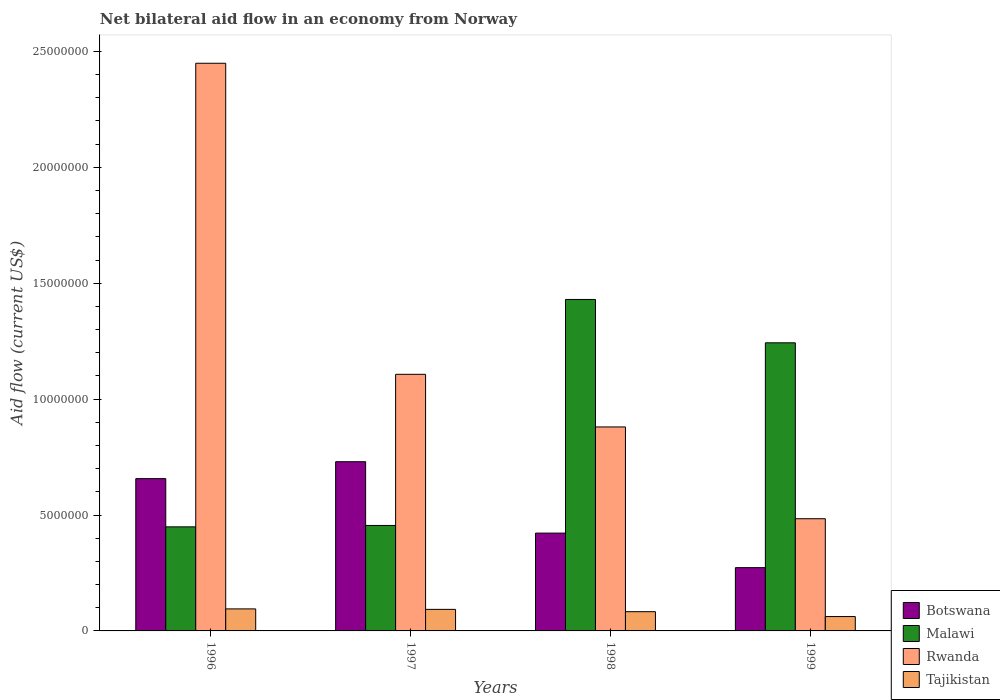How many different coloured bars are there?
Give a very brief answer. 4. How many groups of bars are there?
Offer a very short reply. 4. Are the number of bars per tick equal to the number of legend labels?
Offer a very short reply. Yes. How many bars are there on the 4th tick from the left?
Your answer should be very brief. 4. What is the net bilateral aid flow in Malawi in 1997?
Offer a terse response. 4.55e+06. Across all years, what is the maximum net bilateral aid flow in Botswana?
Your answer should be compact. 7.30e+06. Across all years, what is the minimum net bilateral aid flow in Malawi?
Make the answer very short. 4.49e+06. In which year was the net bilateral aid flow in Rwanda maximum?
Provide a short and direct response. 1996. What is the total net bilateral aid flow in Rwanda in the graph?
Give a very brief answer. 4.92e+07. What is the difference between the net bilateral aid flow in Botswana in 1996 and that in 1998?
Your answer should be compact. 2.35e+06. What is the difference between the net bilateral aid flow in Tajikistan in 1997 and the net bilateral aid flow in Malawi in 1999?
Make the answer very short. -1.15e+07. What is the average net bilateral aid flow in Tajikistan per year?
Your answer should be compact. 8.32e+05. In the year 1997, what is the difference between the net bilateral aid flow in Malawi and net bilateral aid flow in Tajikistan?
Your response must be concise. 3.62e+06. In how many years, is the net bilateral aid flow in Tajikistan greater than 3000000 US$?
Provide a short and direct response. 0. What is the ratio of the net bilateral aid flow in Tajikistan in 1996 to that in 1999?
Offer a very short reply. 1.53. Is the net bilateral aid flow in Tajikistan in 1998 less than that in 1999?
Your answer should be very brief. No. Is the difference between the net bilateral aid flow in Malawi in 1996 and 1998 greater than the difference between the net bilateral aid flow in Tajikistan in 1996 and 1998?
Your answer should be compact. No. What is the difference between the highest and the second highest net bilateral aid flow in Malawi?
Ensure brevity in your answer.  1.87e+06. What is the difference between the highest and the lowest net bilateral aid flow in Tajikistan?
Provide a short and direct response. 3.30e+05. What does the 2nd bar from the left in 1996 represents?
Make the answer very short. Malawi. What does the 4th bar from the right in 1998 represents?
Offer a terse response. Botswana. How many bars are there?
Give a very brief answer. 16. Are the values on the major ticks of Y-axis written in scientific E-notation?
Your answer should be compact. No. Where does the legend appear in the graph?
Offer a very short reply. Bottom right. How many legend labels are there?
Offer a very short reply. 4. What is the title of the graph?
Offer a very short reply. Net bilateral aid flow in an economy from Norway. Does "Haiti" appear as one of the legend labels in the graph?
Offer a terse response. No. What is the label or title of the Y-axis?
Offer a very short reply. Aid flow (current US$). What is the Aid flow (current US$) of Botswana in 1996?
Keep it short and to the point. 6.57e+06. What is the Aid flow (current US$) of Malawi in 1996?
Your answer should be very brief. 4.49e+06. What is the Aid flow (current US$) in Rwanda in 1996?
Give a very brief answer. 2.45e+07. What is the Aid flow (current US$) of Tajikistan in 1996?
Ensure brevity in your answer.  9.50e+05. What is the Aid flow (current US$) of Botswana in 1997?
Your answer should be compact. 7.30e+06. What is the Aid flow (current US$) of Malawi in 1997?
Your answer should be compact. 4.55e+06. What is the Aid flow (current US$) in Rwanda in 1997?
Offer a terse response. 1.11e+07. What is the Aid flow (current US$) of Tajikistan in 1997?
Ensure brevity in your answer.  9.30e+05. What is the Aid flow (current US$) in Botswana in 1998?
Your answer should be very brief. 4.22e+06. What is the Aid flow (current US$) in Malawi in 1998?
Your response must be concise. 1.43e+07. What is the Aid flow (current US$) in Rwanda in 1998?
Give a very brief answer. 8.80e+06. What is the Aid flow (current US$) of Tajikistan in 1998?
Give a very brief answer. 8.30e+05. What is the Aid flow (current US$) of Botswana in 1999?
Offer a very short reply. 2.73e+06. What is the Aid flow (current US$) of Malawi in 1999?
Keep it short and to the point. 1.24e+07. What is the Aid flow (current US$) in Rwanda in 1999?
Make the answer very short. 4.84e+06. What is the Aid flow (current US$) of Tajikistan in 1999?
Keep it short and to the point. 6.20e+05. Across all years, what is the maximum Aid flow (current US$) in Botswana?
Provide a succinct answer. 7.30e+06. Across all years, what is the maximum Aid flow (current US$) in Malawi?
Make the answer very short. 1.43e+07. Across all years, what is the maximum Aid flow (current US$) of Rwanda?
Your response must be concise. 2.45e+07. Across all years, what is the maximum Aid flow (current US$) in Tajikistan?
Your answer should be compact. 9.50e+05. Across all years, what is the minimum Aid flow (current US$) in Botswana?
Your response must be concise. 2.73e+06. Across all years, what is the minimum Aid flow (current US$) in Malawi?
Make the answer very short. 4.49e+06. Across all years, what is the minimum Aid flow (current US$) of Rwanda?
Your answer should be compact. 4.84e+06. Across all years, what is the minimum Aid flow (current US$) of Tajikistan?
Your answer should be very brief. 6.20e+05. What is the total Aid flow (current US$) of Botswana in the graph?
Your response must be concise. 2.08e+07. What is the total Aid flow (current US$) of Malawi in the graph?
Your answer should be very brief. 3.58e+07. What is the total Aid flow (current US$) of Rwanda in the graph?
Offer a terse response. 4.92e+07. What is the total Aid flow (current US$) of Tajikistan in the graph?
Your answer should be very brief. 3.33e+06. What is the difference between the Aid flow (current US$) of Botswana in 1996 and that in 1997?
Your answer should be very brief. -7.30e+05. What is the difference between the Aid flow (current US$) in Malawi in 1996 and that in 1997?
Give a very brief answer. -6.00e+04. What is the difference between the Aid flow (current US$) of Rwanda in 1996 and that in 1997?
Ensure brevity in your answer.  1.34e+07. What is the difference between the Aid flow (current US$) of Tajikistan in 1996 and that in 1997?
Your response must be concise. 2.00e+04. What is the difference between the Aid flow (current US$) of Botswana in 1996 and that in 1998?
Your answer should be compact. 2.35e+06. What is the difference between the Aid flow (current US$) of Malawi in 1996 and that in 1998?
Give a very brief answer. -9.81e+06. What is the difference between the Aid flow (current US$) of Rwanda in 1996 and that in 1998?
Keep it short and to the point. 1.57e+07. What is the difference between the Aid flow (current US$) in Botswana in 1996 and that in 1999?
Ensure brevity in your answer.  3.84e+06. What is the difference between the Aid flow (current US$) of Malawi in 1996 and that in 1999?
Provide a short and direct response. -7.94e+06. What is the difference between the Aid flow (current US$) of Rwanda in 1996 and that in 1999?
Your answer should be very brief. 1.96e+07. What is the difference between the Aid flow (current US$) of Tajikistan in 1996 and that in 1999?
Your response must be concise. 3.30e+05. What is the difference between the Aid flow (current US$) in Botswana in 1997 and that in 1998?
Your response must be concise. 3.08e+06. What is the difference between the Aid flow (current US$) in Malawi in 1997 and that in 1998?
Keep it short and to the point. -9.75e+06. What is the difference between the Aid flow (current US$) of Rwanda in 1997 and that in 1998?
Provide a succinct answer. 2.27e+06. What is the difference between the Aid flow (current US$) of Botswana in 1997 and that in 1999?
Your answer should be compact. 4.57e+06. What is the difference between the Aid flow (current US$) of Malawi in 1997 and that in 1999?
Your answer should be compact. -7.88e+06. What is the difference between the Aid flow (current US$) in Rwanda in 1997 and that in 1999?
Make the answer very short. 6.23e+06. What is the difference between the Aid flow (current US$) of Botswana in 1998 and that in 1999?
Give a very brief answer. 1.49e+06. What is the difference between the Aid flow (current US$) in Malawi in 1998 and that in 1999?
Offer a terse response. 1.87e+06. What is the difference between the Aid flow (current US$) of Rwanda in 1998 and that in 1999?
Make the answer very short. 3.96e+06. What is the difference between the Aid flow (current US$) in Tajikistan in 1998 and that in 1999?
Your response must be concise. 2.10e+05. What is the difference between the Aid flow (current US$) of Botswana in 1996 and the Aid flow (current US$) of Malawi in 1997?
Provide a succinct answer. 2.02e+06. What is the difference between the Aid flow (current US$) in Botswana in 1996 and the Aid flow (current US$) in Rwanda in 1997?
Offer a terse response. -4.50e+06. What is the difference between the Aid flow (current US$) of Botswana in 1996 and the Aid flow (current US$) of Tajikistan in 1997?
Make the answer very short. 5.64e+06. What is the difference between the Aid flow (current US$) in Malawi in 1996 and the Aid flow (current US$) in Rwanda in 1997?
Make the answer very short. -6.58e+06. What is the difference between the Aid flow (current US$) in Malawi in 1996 and the Aid flow (current US$) in Tajikistan in 1997?
Your response must be concise. 3.56e+06. What is the difference between the Aid flow (current US$) of Rwanda in 1996 and the Aid flow (current US$) of Tajikistan in 1997?
Your answer should be very brief. 2.36e+07. What is the difference between the Aid flow (current US$) of Botswana in 1996 and the Aid flow (current US$) of Malawi in 1998?
Offer a very short reply. -7.73e+06. What is the difference between the Aid flow (current US$) of Botswana in 1996 and the Aid flow (current US$) of Rwanda in 1998?
Offer a very short reply. -2.23e+06. What is the difference between the Aid flow (current US$) in Botswana in 1996 and the Aid flow (current US$) in Tajikistan in 1998?
Keep it short and to the point. 5.74e+06. What is the difference between the Aid flow (current US$) of Malawi in 1996 and the Aid flow (current US$) of Rwanda in 1998?
Provide a short and direct response. -4.31e+06. What is the difference between the Aid flow (current US$) of Malawi in 1996 and the Aid flow (current US$) of Tajikistan in 1998?
Offer a terse response. 3.66e+06. What is the difference between the Aid flow (current US$) of Rwanda in 1996 and the Aid flow (current US$) of Tajikistan in 1998?
Your answer should be very brief. 2.37e+07. What is the difference between the Aid flow (current US$) in Botswana in 1996 and the Aid flow (current US$) in Malawi in 1999?
Offer a very short reply. -5.86e+06. What is the difference between the Aid flow (current US$) of Botswana in 1996 and the Aid flow (current US$) of Rwanda in 1999?
Keep it short and to the point. 1.73e+06. What is the difference between the Aid flow (current US$) in Botswana in 1996 and the Aid flow (current US$) in Tajikistan in 1999?
Your answer should be very brief. 5.95e+06. What is the difference between the Aid flow (current US$) of Malawi in 1996 and the Aid flow (current US$) of Rwanda in 1999?
Ensure brevity in your answer.  -3.50e+05. What is the difference between the Aid flow (current US$) of Malawi in 1996 and the Aid flow (current US$) of Tajikistan in 1999?
Your response must be concise. 3.87e+06. What is the difference between the Aid flow (current US$) in Rwanda in 1996 and the Aid flow (current US$) in Tajikistan in 1999?
Keep it short and to the point. 2.39e+07. What is the difference between the Aid flow (current US$) of Botswana in 1997 and the Aid flow (current US$) of Malawi in 1998?
Provide a succinct answer. -7.00e+06. What is the difference between the Aid flow (current US$) of Botswana in 1997 and the Aid flow (current US$) of Rwanda in 1998?
Your answer should be compact. -1.50e+06. What is the difference between the Aid flow (current US$) in Botswana in 1997 and the Aid flow (current US$) in Tajikistan in 1998?
Your answer should be compact. 6.47e+06. What is the difference between the Aid flow (current US$) of Malawi in 1997 and the Aid flow (current US$) of Rwanda in 1998?
Give a very brief answer. -4.25e+06. What is the difference between the Aid flow (current US$) of Malawi in 1997 and the Aid flow (current US$) of Tajikistan in 1998?
Give a very brief answer. 3.72e+06. What is the difference between the Aid flow (current US$) in Rwanda in 1997 and the Aid flow (current US$) in Tajikistan in 1998?
Offer a terse response. 1.02e+07. What is the difference between the Aid flow (current US$) in Botswana in 1997 and the Aid flow (current US$) in Malawi in 1999?
Provide a short and direct response. -5.13e+06. What is the difference between the Aid flow (current US$) of Botswana in 1997 and the Aid flow (current US$) of Rwanda in 1999?
Provide a short and direct response. 2.46e+06. What is the difference between the Aid flow (current US$) of Botswana in 1997 and the Aid flow (current US$) of Tajikistan in 1999?
Make the answer very short. 6.68e+06. What is the difference between the Aid flow (current US$) in Malawi in 1997 and the Aid flow (current US$) in Rwanda in 1999?
Your answer should be compact. -2.90e+05. What is the difference between the Aid flow (current US$) in Malawi in 1997 and the Aid flow (current US$) in Tajikistan in 1999?
Make the answer very short. 3.93e+06. What is the difference between the Aid flow (current US$) of Rwanda in 1997 and the Aid flow (current US$) of Tajikistan in 1999?
Ensure brevity in your answer.  1.04e+07. What is the difference between the Aid flow (current US$) of Botswana in 1998 and the Aid flow (current US$) of Malawi in 1999?
Provide a short and direct response. -8.21e+06. What is the difference between the Aid flow (current US$) in Botswana in 1998 and the Aid flow (current US$) in Rwanda in 1999?
Make the answer very short. -6.20e+05. What is the difference between the Aid flow (current US$) in Botswana in 1998 and the Aid flow (current US$) in Tajikistan in 1999?
Give a very brief answer. 3.60e+06. What is the difference between the Aid flow (current US$) in Malawi in 1998 and the Aid flow (current US$) in Rwanda in 1999?
Give a very brief answer. 9.46e+06. What is the difference between the Aid flow (current US$) of Malawi in 1998 and the Aid flow (current US$) of Tajikistan in 1999?
Provide a short and direct response. 1.37e+07. What is the difference between the Aid flow (current US$) of Rwanda in 1998 and the Aid flow (current US$) of Tajikistan in 1999?
Offer a terse response. 8.18e+06. What is the average Aid flow (current US$) of Botswana per year?
Ensure brevity in your answer.  5.20e+06. What is the average Aid flow (current US$) of Malawi per year?
Your answer should be compact. 8.94e+06. What is the average Aid flow (current US$) in Rwanda per year?
Offer a very short reply. 1.23e+07. What is the average Aid flow (current US$) in Tajikistan per year?
Make the answer very short. 8.32e+05. In the year 1996, what is the difference between the Aid flow (current US$) in Botswana and Aid flow (current US$) in Malawi?
Make the answer very short. 2.08e+06. In the year 1996, what is the difference between the Aid flow (current US$) in Botswana and Aid flow (current US$) in Rwanda?
Your answer should be compact. -1.79e+07. In the year 1996, what is the difference between the Aid flow (current US$) of Botswana and Aid flow (current US$) of Tajikistan?
Provide a short and direct response. 5.62e+06. In the year 1996, what is the difference between the Aid flow (current US$) of Malawi and Aid flow (current US$) of Rwanda?
Provide a short and direct response. -2.00e+07. In the year 1996, what is the difference between the Aid flow (current US$) of Malawi and Aid flow (current US$) of Tajikistan?
Provide a short and direct response. 3.54e+06. In the year 1996, what is the difference between the Aid flow (current US$) in Rwanda and Aid flow (current US$) in Tajikistan?
Your answer should be very brief. 2.35e+07. In the year 1997, what is the difference between the Aid flow (current US$) of Botswana and Aid flow (current US$) of Malawi?
Offer a terse response. 2.75e+06. In the year 1997, what is the difference between the Aid flow (current US$) of Botswana and Aid flow (current US$) of Rwanda?
Your answer should be very brief. -3.77e+06. In the year 1997, what is the difference between the Aid flow (current US$) of Botswana and Aid flow (current US$) of Tajikistan?
Make the answer very short. 6.37e+06. In the year 1997, what is the difference between the Aid flow (current US$) in Malawi and Aid flow (current US$) in Rwanda?
Provide a short and direct response. -6.52e+06. In the year 1997, what is the difference between the Aid flow (current US$) of Malawi and Aid flow (current US$) of Tajikistan?
Offer a terse response. 3.62e+06. In the year 1997, what is the difference between the Aid flow (current US$) of Rwanda and Aid flow (current US$) of Tajikistan?
Provide a short and direct response. 1.01e+07. In the year 1998, what is the difference between the Aid flow (current US$) of Botswana and Aid flow (current US$) of Malawi?
Your answer should be very brief. -1.01e+07. In the year 1998, what is the difference between the Aid flow (current US$) in Botswana and Aid flow (current US$) in Rwanda?
Your response must be concise. -4.58e+06. In the year 1998, what is the difference between the Aid flow (current US$) in Botswana and Aid flow (current US$) in Tajikistan?
Make the answer very short. 3.39e+06. In the year 1998, what is the difference between the Aid flow (current US$) in Malawi and Aid flow (current US$) in Rwanda?
Your answer should be compact. 5.50e+06. In the year 1998, what is the difference between the Aid flow (current US$) in Malawi and Aid flow (current US$) in Tajikistan?
Ensure brevity in your answer.  1.35e+07. In the year 1998, what is the difference between the Aid flow (current US$) of Rwanda and Aid flow (current US$) of Tajikistan?
Keep it short and to the point. 7.97e+06. In the year 1999, what is the difference between the Aid flow (current US$) in Botswana and Aid flow (current US$) in Malawi?
Make the answer very short. -9.70e+06. In the year 1999, what is the difference between the Aid flow (current US$) in Botswana and Aid flow (current US$) in Rwanda?
Provide a short and direct response. -2.11e+06. In the year 1999, what is the difference between the Aid flow (current US$) of Botswana and Aid flow (current US$) of Tajikistan?
Offer a terse response. 2.11e+06. In the year 1999, what is the difference between the Aid flow (current US$) of Malawi and Aid flow (current US$) of Rwanda?
Offer a terse response. 7.59e+06. In the year 1999, what is the difference between the Aid flow (current US$) of Malawi and Aid flow (current US$) of Tajikistan?
Your answer should be very brief. 1.18e+07. In the year 1999, what is the difference between the Aid flow (current US$) in Rwanda and Aid flow (current US$) in Tajikistan?
Offer a terse response. 4.22e+06. What is the ratio of the Aid flow (current US$) of Rwanda in 1996 to that in 1997?
Keep it short and to the point. 2.21. What is the ratio of the Aid flow (current US$) of Tajikistan in 1996 to that in 1997?
Offer a very short reply. 1.02. What is the ratio of the Aid flow (current US$) in Botswana in 1996 to that in 1998?
Provide a succinct answer. 1.56. What is the ratio of the Aid flow (current US$) in Malawi in 1996 to that in 1998?
Your response must be concise. 0.31. What is the ratio of the Aid flow (current US$) in Rwanda in 1996 to that in 1998?
Offer a very short reply. 2.78. What is the ratio of the Aid flow (current US$) of Tajikistan in 1996 to that in 1998?
Offer a terse response. 1.14. What is the ratio of the Aid flow (current US$) in Botswana in 1996 to that in 1999?
Ensure brevity in your answer.  2.41. What is the ratio of the Aid flow (current US$) of Malawi in 1996 to that in 1999?
Offer a terse response. 0.36. What is the ratio of the Aid flow (current US$) of Rwanda in 1996 to that in 1999?
Give a very brief answer. 5.06. What is the ratio of the Aid flow (current US$) in Tajikistan in 1996 to that in 1999?
Give a very brief answer. 1.53. What is the ratio of the Aid flow (current US$) in Botswana in 1997 to that in 1998?
Offer a terse response. 1.73. What is the ratio of the Aid flow (current US$) of Malawi in 1997 to that in 1998?
Offer a terse response. 0.32. What is the ratio of the Aid flow (current US$) of Rwanda in 1997 to that in 1998?
Your response must be concise. 1.26. What is the ratio of the Aid flow (current US$) in Tajikistan in 1997 to that in 1998?
Keep it short and to the point. 1.12. What is the ratio of the Aid flow (current US$) of Botswana in 1997 to that in 1999?
Give a very brief answer. 2.67. What is the ratio of the Aid flow (current US$) in Malawi in 1997 to that in 1999?
Give a very brief answer. 0.37. What is the ratio of the Aid flow (current US$) in Rwanda in 1997 to that in 1999?
Your answer should be compact. 2.29. What is the ratio of the Aid flow (current US$) of Botswana in 1998 to that in 1999?
Your response must be concise. 1.55. What is the ratio of the Aid flow (current US$) in Malawi in 1998 to that in 1999?
Offer a very short reply. 1.15. What is the ratio of the Aid flow (current US$) in Rwanda in 1998 to that in 1999?
Provide a short and direct response. 1.82. What is the ratio of the Aid flow (current US$) in Tajikistan in 1998 to that in 1999?
Provide a short and direct response. 1.34. What is the difference between the highest and the second highest Aid flow (current US$) in Botswana?
Provide a short and direct response. 7.30e+05. What is the difference between the highest and the second highest Aid flow (current US$) of Malawi?
Offer a terse response. 1.87e+06. What is the difference between the highest and the second highest Aid flow (current US$) of Rwanda?
Offer a very short reply. 1.34e+07. What is the difference between the highest and the lowest Aid flow (current US$) in Botswana?
Provide a succinct answer. 4.57e+06. What is the difference between the highest and the lowest Aid flow (current US$) of Malawi?
Provide a short and direct response. 9.81e+06. What is the difference between the highest and the lowest Aid flow (current US$) of Rwanda?
Your answer should be compact. 1.96e+07. What is the difference between the highest and the lowest Aid flow (current US$) of Tajikistan?
Your answer should be very brief. 3.30e+05. 